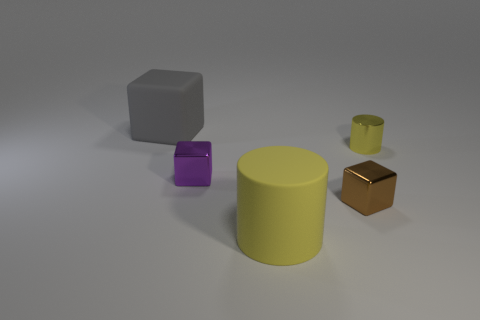How many things are either shiny balls or metal objects? In the image, there are no shiny balls; however, there are three objects that appear to be made of metal: a gray cube, a yellow cylinder, and a small brown cube. 